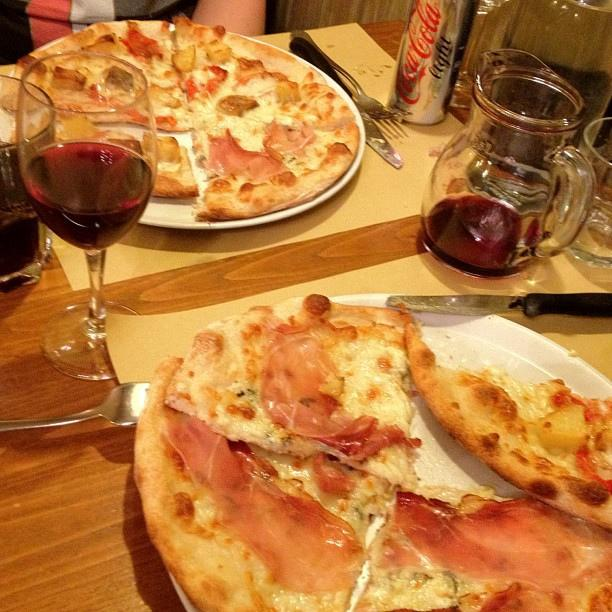Where would you most likely see this type of pizza served with wine?

Choices:
A) uk
B) canada
C) italy
D) usa italy 